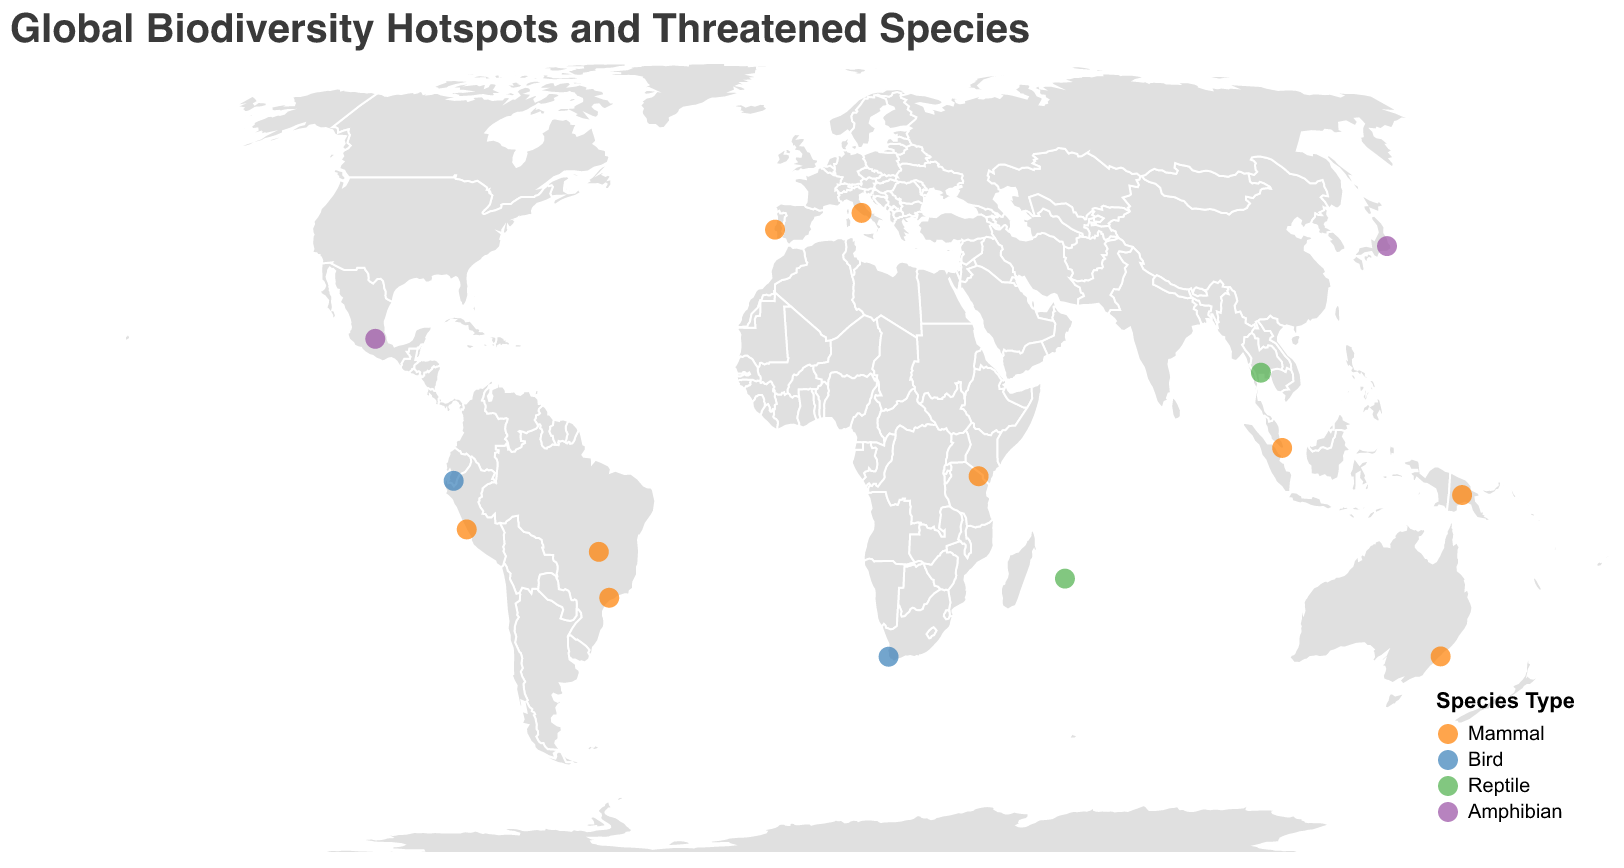What's the title of the figure? The title is displayed at the top of the figure; it reads "Global Biodiversity Hotspots and Threatened Species".
Answer: Global Biodiversity Hotspots and Threatened Species How many biodiversity hotspots are depicted in the figure? By counting the number of unique locations marked with circles on the map, we can identify the total number of biodiversity hotspots.
Answer: 15 Which species type is represented by the color orange? By checking the legend of the figure, we can see that the color orange corresponds to the "Mammal" species type.
Answer: Mammal How many hotspots have threatened species of the Mammal type? By filtering the data points identified as Mammals (orange circles), we can count the total occurrences. There are 9 Mammals listed in the dataset.
Answer: 9 Which hotspot features the threatened species "Koala"? By identifying the data point associated with the threatened species "Koala", we find it is located in the "East Australian Temperate Forests" hotspot.
Answer: East Australian Temperate Forests Compare the number of threatened species from the Bird category with the Reptile category. Which category has more species? By counting the data points for each category, we see there are 2 Bird species and 2 Reptile species. Therefore, both categories have the same number.
Answer: Same number Which hotspot is located nearest to the equator? The equator is at latitude 0. By comparing the absolute values of the latitudes, the smallest absolute latitude value is +1.3521 for Sundaland.
Answer: Sundaland Which category has the highest diversity of species in the figure? By counting the number of unique threatened species in each category, we find that Mammals, with 9 species, have the highest diversity.
Answer: Mammal What threatened species are found in the Mediterranean Basin hotspot? By examining the data for endangered species listed under the "Mediterranean Basin" hotspot, we see "Iberian Lynx" and "Monk Seal".
Answer: Iberian Lynx and Monk Seal What is the frequency of different species types in the hotspots? By counting the occurrences of each species type in the dataset: Mammals (9 times), Birds (2 times), Reptiles (2 times), and Amphibians (2 times).
Answer: Mammals: 9, Birds: 2, Reptiles: 2, Amphibians: 2 